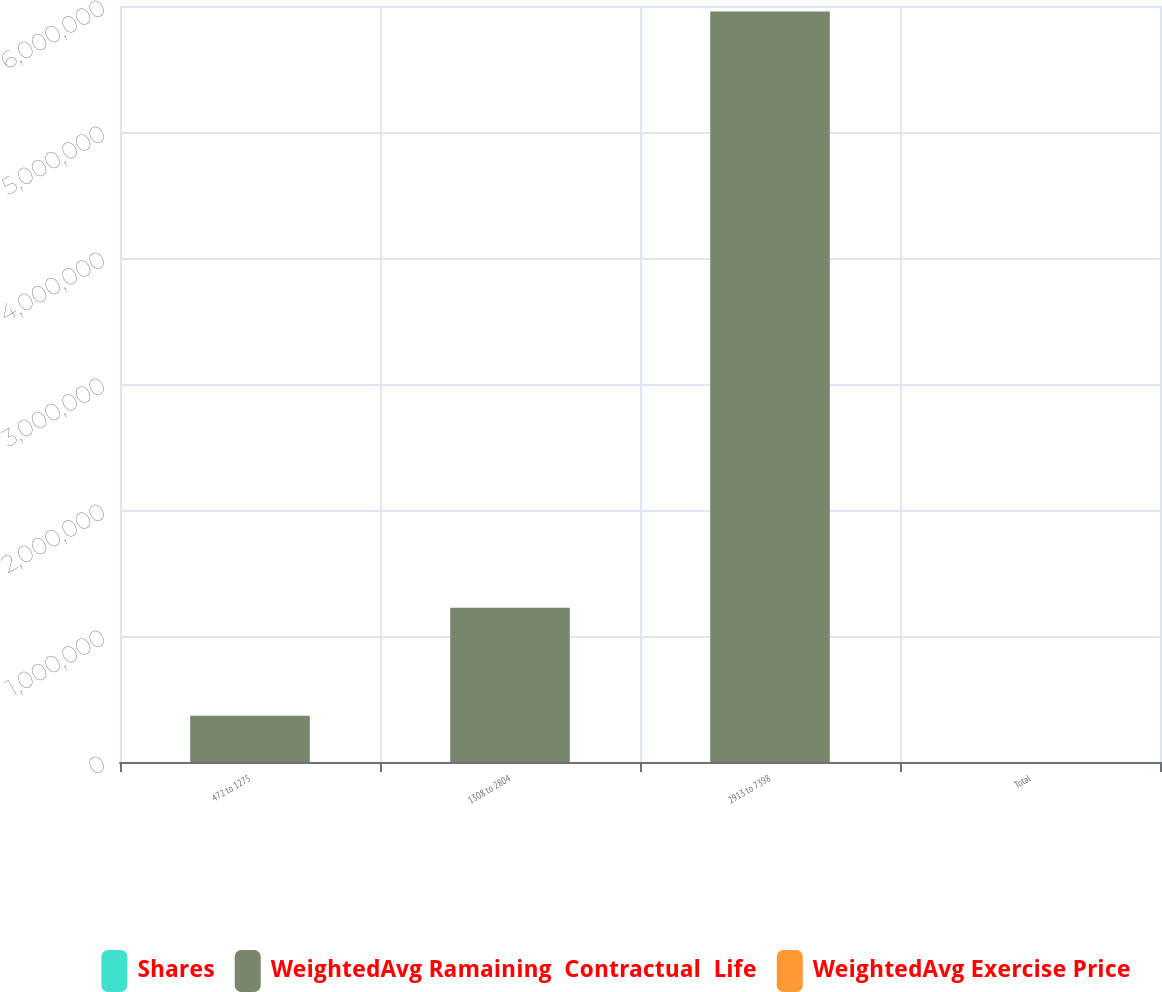Convert chart. <chart><loc_0><loc_0><loc_500><loc_500><stacked_bar_chart><ecel><fcel>472 to 1275<fcel>1308 to 2804<fcel>2913 to 7398<fcel>Total<nl><fcel>Shares<fcel>3.91<fcel>4.61<fcel>8<fcel>7.25<nl><fcel>WeightedAvg Ramaining  Contractual  Life<fcel>366523<fcel>1.22473e+06<fcel>5.95657e+06<fcel>18.03<nl><fcel>WeightedAvg Exercise Price<fcel>9.93<fcel>18.03<fcel>42.88<fcel>37.24<nl></chart> 